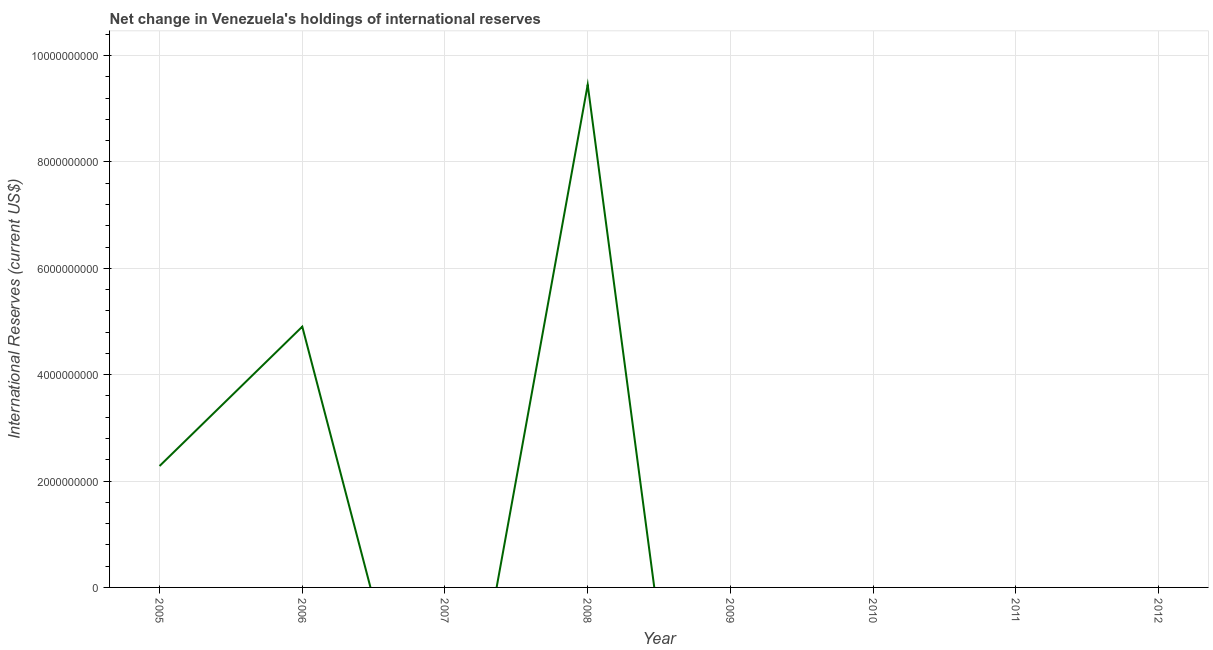What is the reserves and related items in 2006?
Ensure brevity in your answer.  4.90e+09. Across all years, what is the maximum reserves and related items?
Your response must be concise. 9.45e+09. In which year was the reserves and related items maximum?
Offer a very short reply. 2008. What is the sum of the reserves and related items?
Give a very brief answer. 1.66e+1. What is the difference between the reserves and related items in 2005 and 2006?
Your response must be concise. -2.62e+09. What is the average reserves and related items per year?
Keep it short and to the point. 2.08e+09. What is the median reserves and related items?
Offer a terse response. 0. What is the ratio of the reserves and related items in 2005 to that in 2008?
Offer a terse response. 0.24. What is the difference between the highest and the second highest reserves and related items?
Offer a terse response. 4.55e+09. Is the sum of the reserves and related items in 2005 and 2008 greater than the maximum reserves and related items across all years?
Give a very brief answer. Yes. What is the difference between the highest and the lowest reserves and related items?
Make the answer very short. 9.45e+09. How many years are there in the graph?
Your answer should be very brief. 8. What is the difference between two consecutive major ticks on the Y-axis?
Provide a succinct answer. 2.00e+09. Does the graph contain any zero values?
Your response must be concise. Yes. Does the graph contain grids?
Keep it short and to the point. Yes. What is the title of the graph?
Offer a terse response. Net change in Venezuela's holdings of international reserves. What is the label or title of the X-axis?
Offer a very short reply. Year. What is the label or title of the Y-axis?
Your answer should be compact. International Reserves (current US$). What is the International Reserves (current US$) in 2005?
Your response must be concise. 2.28e+09. What is the International Reserves (current US$) in 2006?
Give a very brief answer. 4.90e+09. What is the International Reserves (current US$) of 2007?
Your response must be concise. 0. What is the International Reserves (current US$) in 2008?
Keep it short and to the point. 9.45e+09. What is the difference between the International Reserves (current US$) in 2005 and 2006?
Keep it short and to the point. -2.62e+09. What is the difference between the International Reserves (current US$) in 2005 and 2008?
Your answer should be compact. -7.17e+09. What is the difference between the International Reserves (current US$) in 2006 and 2008?
Your answer should be very brief. -4.55e+09. What is the ratio of the International Reserves (current US$) in 2005 to that in 2006?
Offer a terse response. 0.47. What is the ratio of the International Reserves (current US$) in 2005 to that in 2008?
Your answer should be compact. 0.24. What is the ratio of the International Reserves (current US$) in 2006 to that in 2008?
Provide a succinct answer. 0.52. 